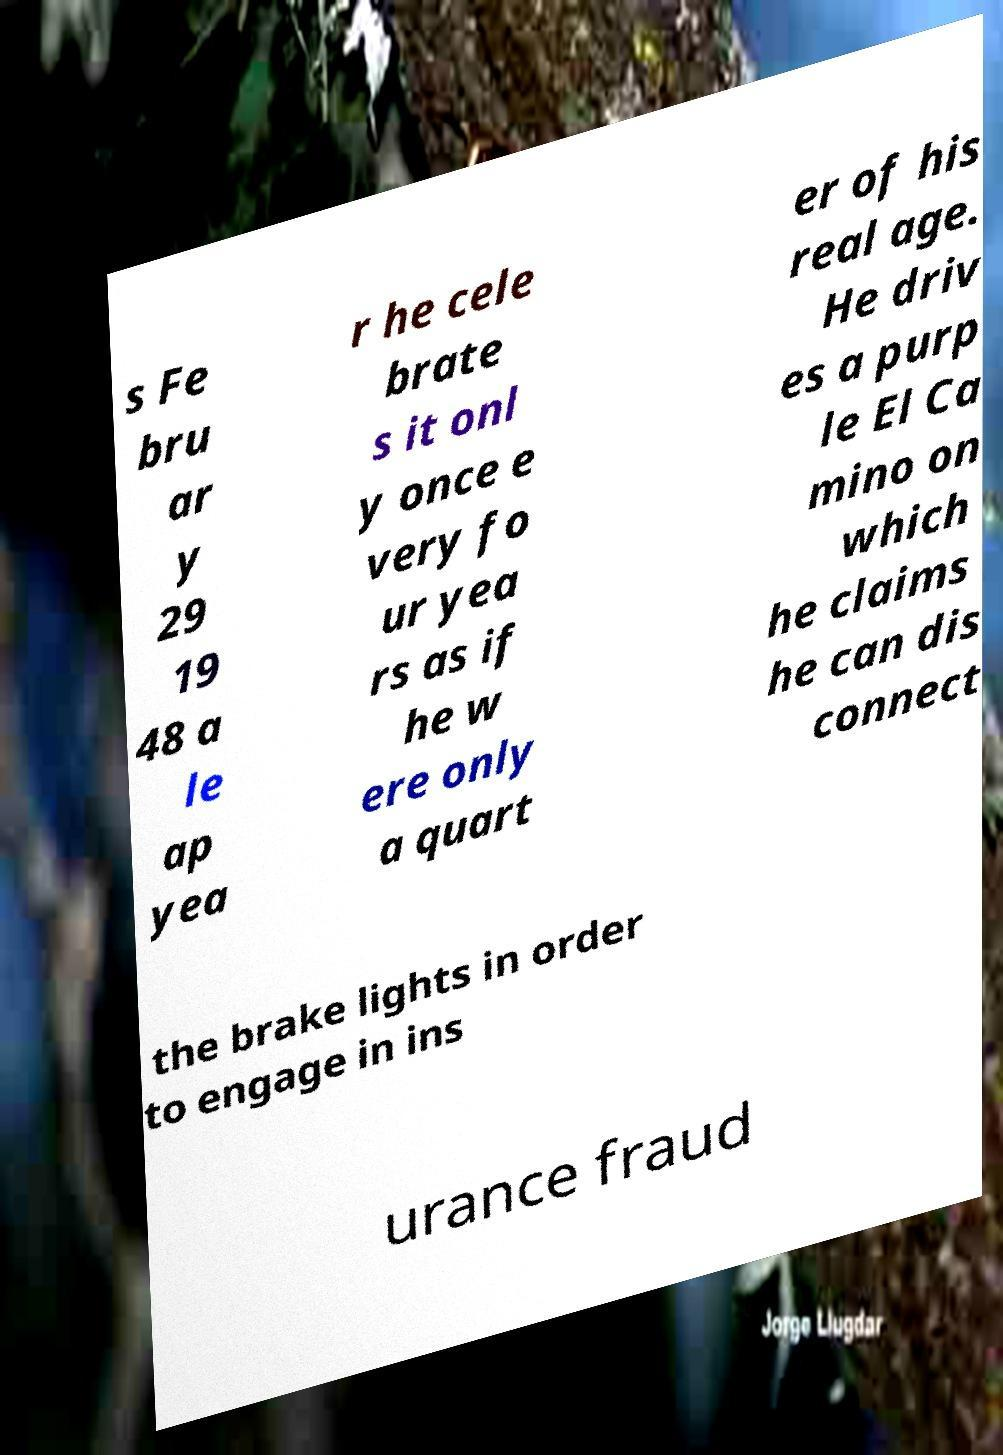Could you extract and type out the text from this image? s Fe bru ar y 29 19 48 a le ap yea r he cele brate s it onl y once e very fo ur yea rs as if he w ere only a quart er of his real age. He driv es a purp le El Ca mino on which he claims he can dis connect the brake lights in order to engage in ins urance fraud 